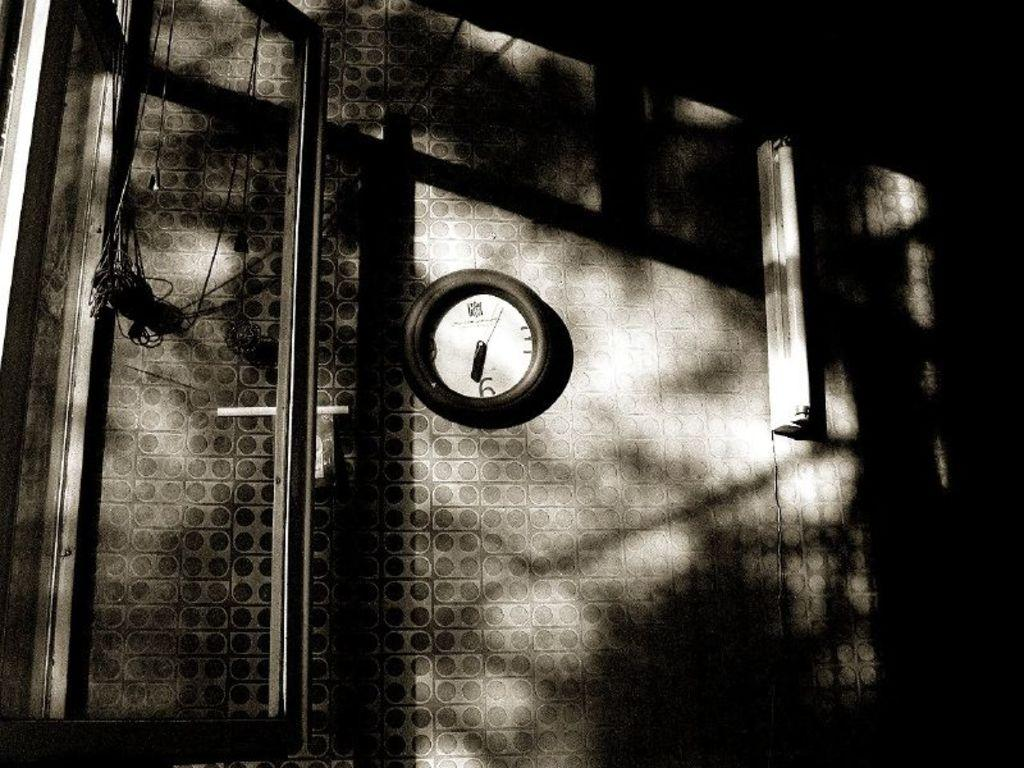What is the color scheme of the image? The image is black and white. What can be seen on the wall in the image? There is a tube light and a clock on the wall. What is located near the wall in the image? There is a stand near the wall. What else can be observed in the image? There are wires visible in the image. Can you tell me how many planes are flying in the image? There are no planes visible in the image; it is a black and white image featuring a wall with a tube light, a clock, and wires. Is there a prison depicted in the image? There is no prison present in the image; it is a close-up view of a wall with a tube light, a clock, and wires. 